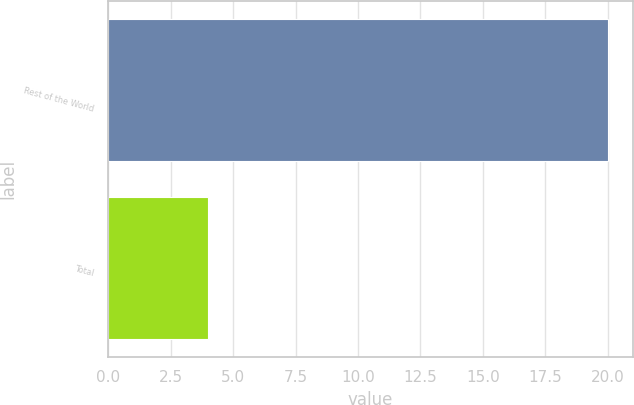Convert chart. <chart><loc_0><loc_0><loc_500><loc_500><bar_chart><fcel>Rest of the World<fcel>Total<nl><fcel>20<fcel>4<nl></chart> 